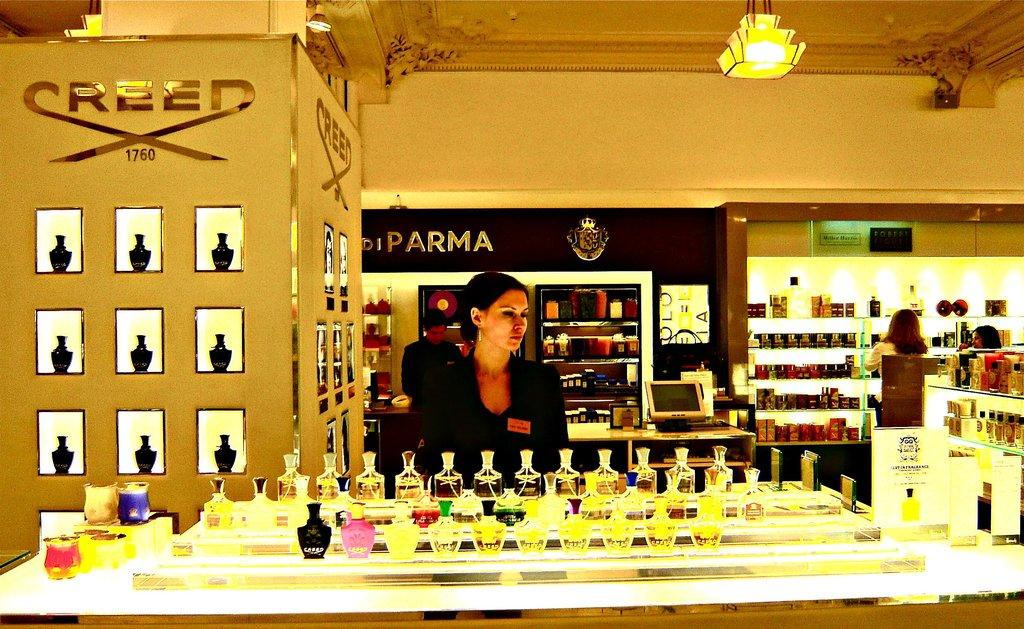<image>
Create a compact narrative representing the image presented. A display counter with a woman behind it and Creed above her head. 